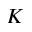Convert formula to latex. <formula><loc_0><loc_0><loc_500><loc_500>K</formula> 